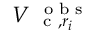Convert formula to latex. <formula><loc_0><loc_0><loc_500><loc_500>V _ { c , r _ { i } } ^ { o b s }</formula> 